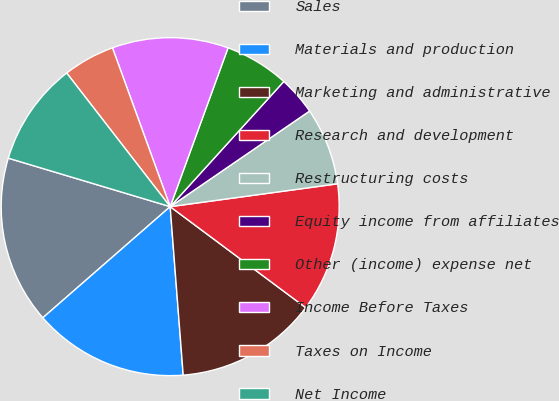Convert chart to OTSL. <chart><loc_0><loc_0><loc_500><loc_500><pie_chart><fcel>Sales<fcel>Materials and production<fcel>Marketing and administrative<fcel>Research and development<fcel>Restructuring costs<fcel>Equity income from affiliates<fcel>Other (income) expense net<fcel>Income Before Taxes<fcel>Taxes on Income<fcel>Net Income<nl><fcel>16.05%<fcel>14.81%<fcel>13.58%<fcel>12.35%<fcel>7.41%<fcel>3.7%<fcel>6.17%<fcel>11.11%<fcel>4.94%<fcel>9.88%<nl></chart> 